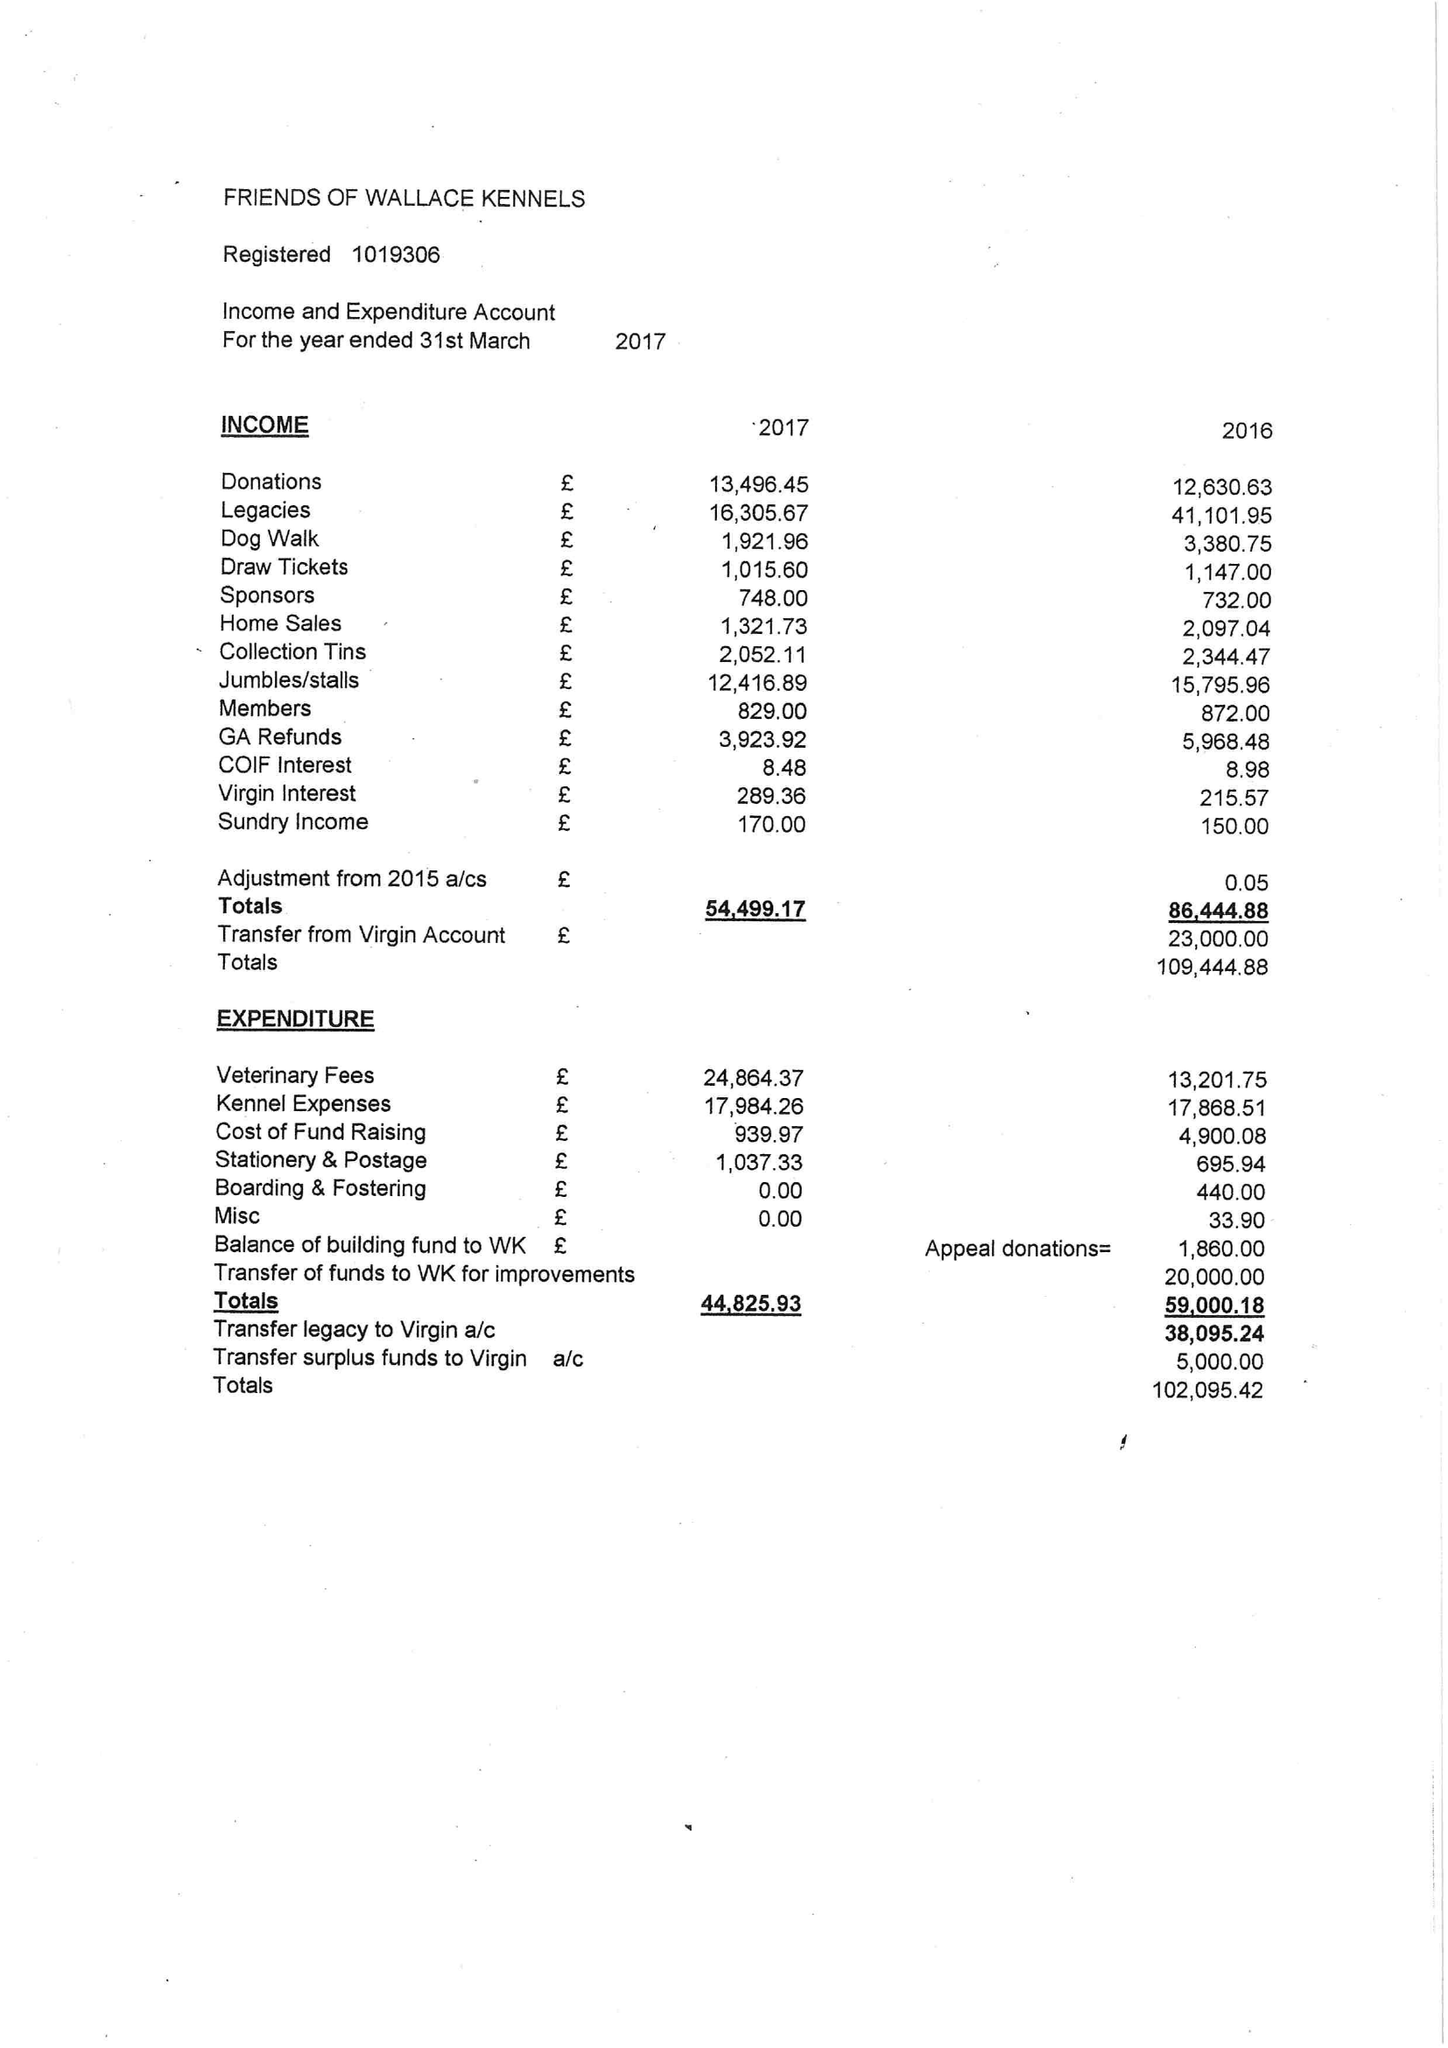What is the value for the address__street_line?
Answer the question using a single word or phrase. 20 STONEY HILLS 